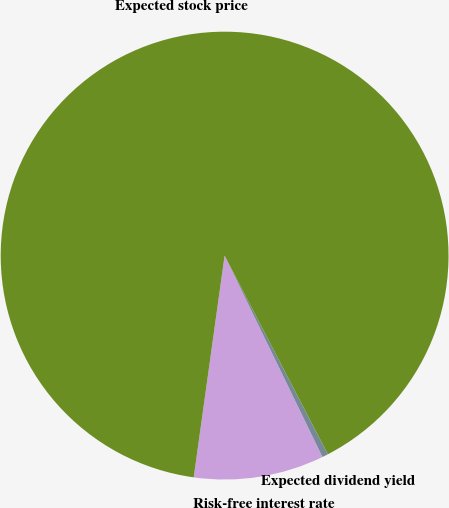<chart> <loc_0><loc_0><loc_500><loc_500><pie_chart><fcel>Risk-free interest rate<fcel>Expected dividend yield<fcel>Expected stock price<nl><fcel>9.4%<fcel>0.43%<fcel>90.16%<nl></chart> 